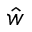<formula> <loc_0><loc_0><loc_500><loc_500>\hat { w }</formula> 